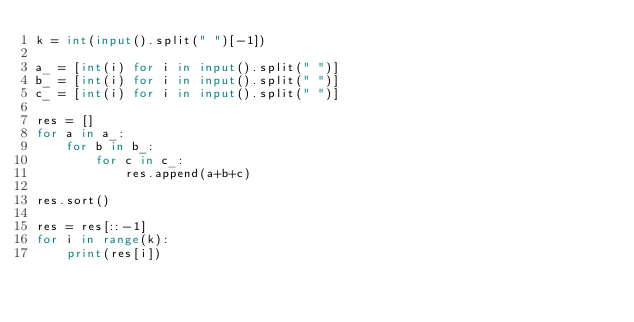<code> <loc_0><loc_0><loc_500><loc_500><_Python_>k = int(input().split(" ")[-1])

a_ = [int(i) for i in input().split(" ")]
b_ = [int(i) for i in input().split(" ")]
c_ = [int(i) for i in input().split(" ")]

res = []
for a in a_:
    for b in b_:
        for c in c_:
            res.append(a+b+c)

res.sort()

res = res[::-1]
for i in range(k):
    print(res[i])</code> 